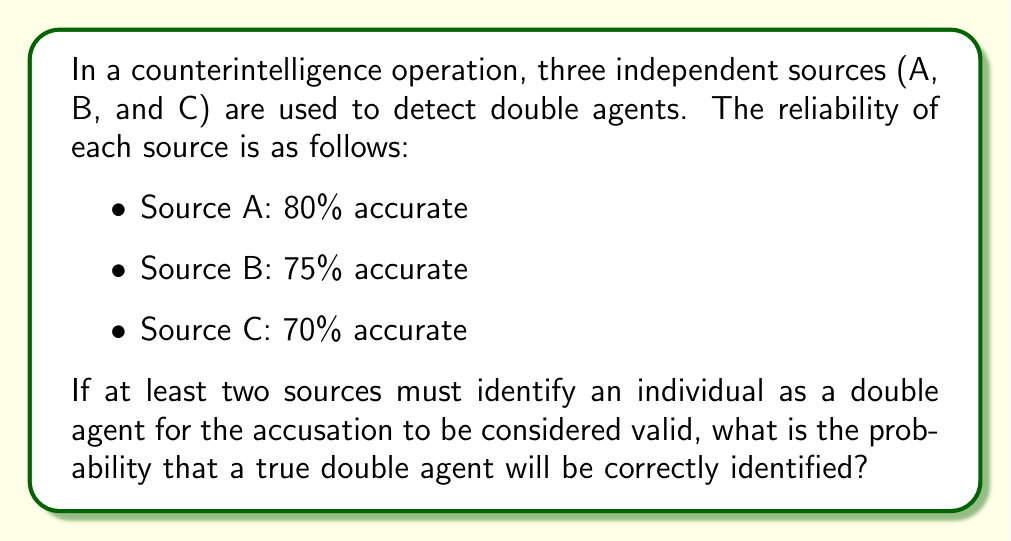Can you answer this question? Let's approach this step-by-step:

1) First, we need to calculate the probability of each source correctly identifying the double agent:
   P(A) = 0.80, P(B) = 0.75, P(C) = 0.70

2) Now, we need to consider all scenarios where at least two sources correctly identify the double agent:
   - All three sources are correct
   - A and B are correct, C is incorrect
   - A and C are correct, B is incorrect
   - B and C are correct, A is incorrect

3) Let's calculate each probability:
   
   P(All correct) = P(A) * P(B) * P(C)
   $$ = 0.80 * 0.75 * 0.70 = 0.42 $$

   P(A and B correct, C incorrect) = P(A) * P(B) * (1 - P(C))
   $$ = 0.80 * 0.75 * 0.30 = 0.18 $$

   P(A and C correct, B incorrect) = P(A) * (1 - P(B)) * P(C)
   $$ = 0.80 * 0.25 * 0.70 = 0.14 $$

   P(B and C correct, A incorrect) = (1 - P(A)) * P(B) * P(C)
   $$ = 0.20 * 0.75 * 0.70 = 0.105 $$

4) The total probability is the sum of all these scenarios:

   P(correct identification) = 0.42 + 0.18 + 0.14 + 0.105 = 0.845

Therefore, the probability that a true double agent will be correctly identified is 0.845 or 84.5%.
Answer: 0.845 